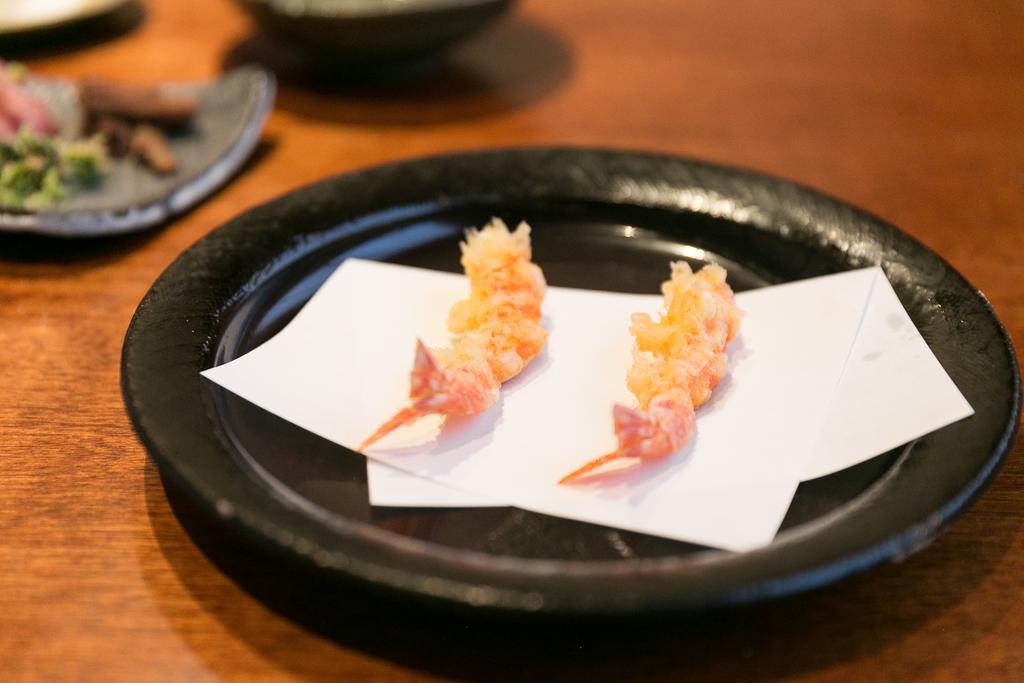In one or two sentences, can you explain what this image depicts? In the image we can see a table, on the table we can see some plates. In the plates we can see some food and papers. 